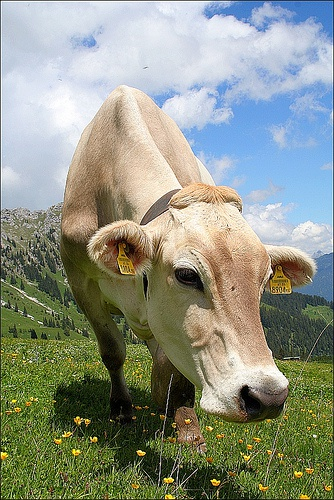Describe the objects in this image and their specific colors. I can see a cow in black, beige, olive, and tan tones in this image. 